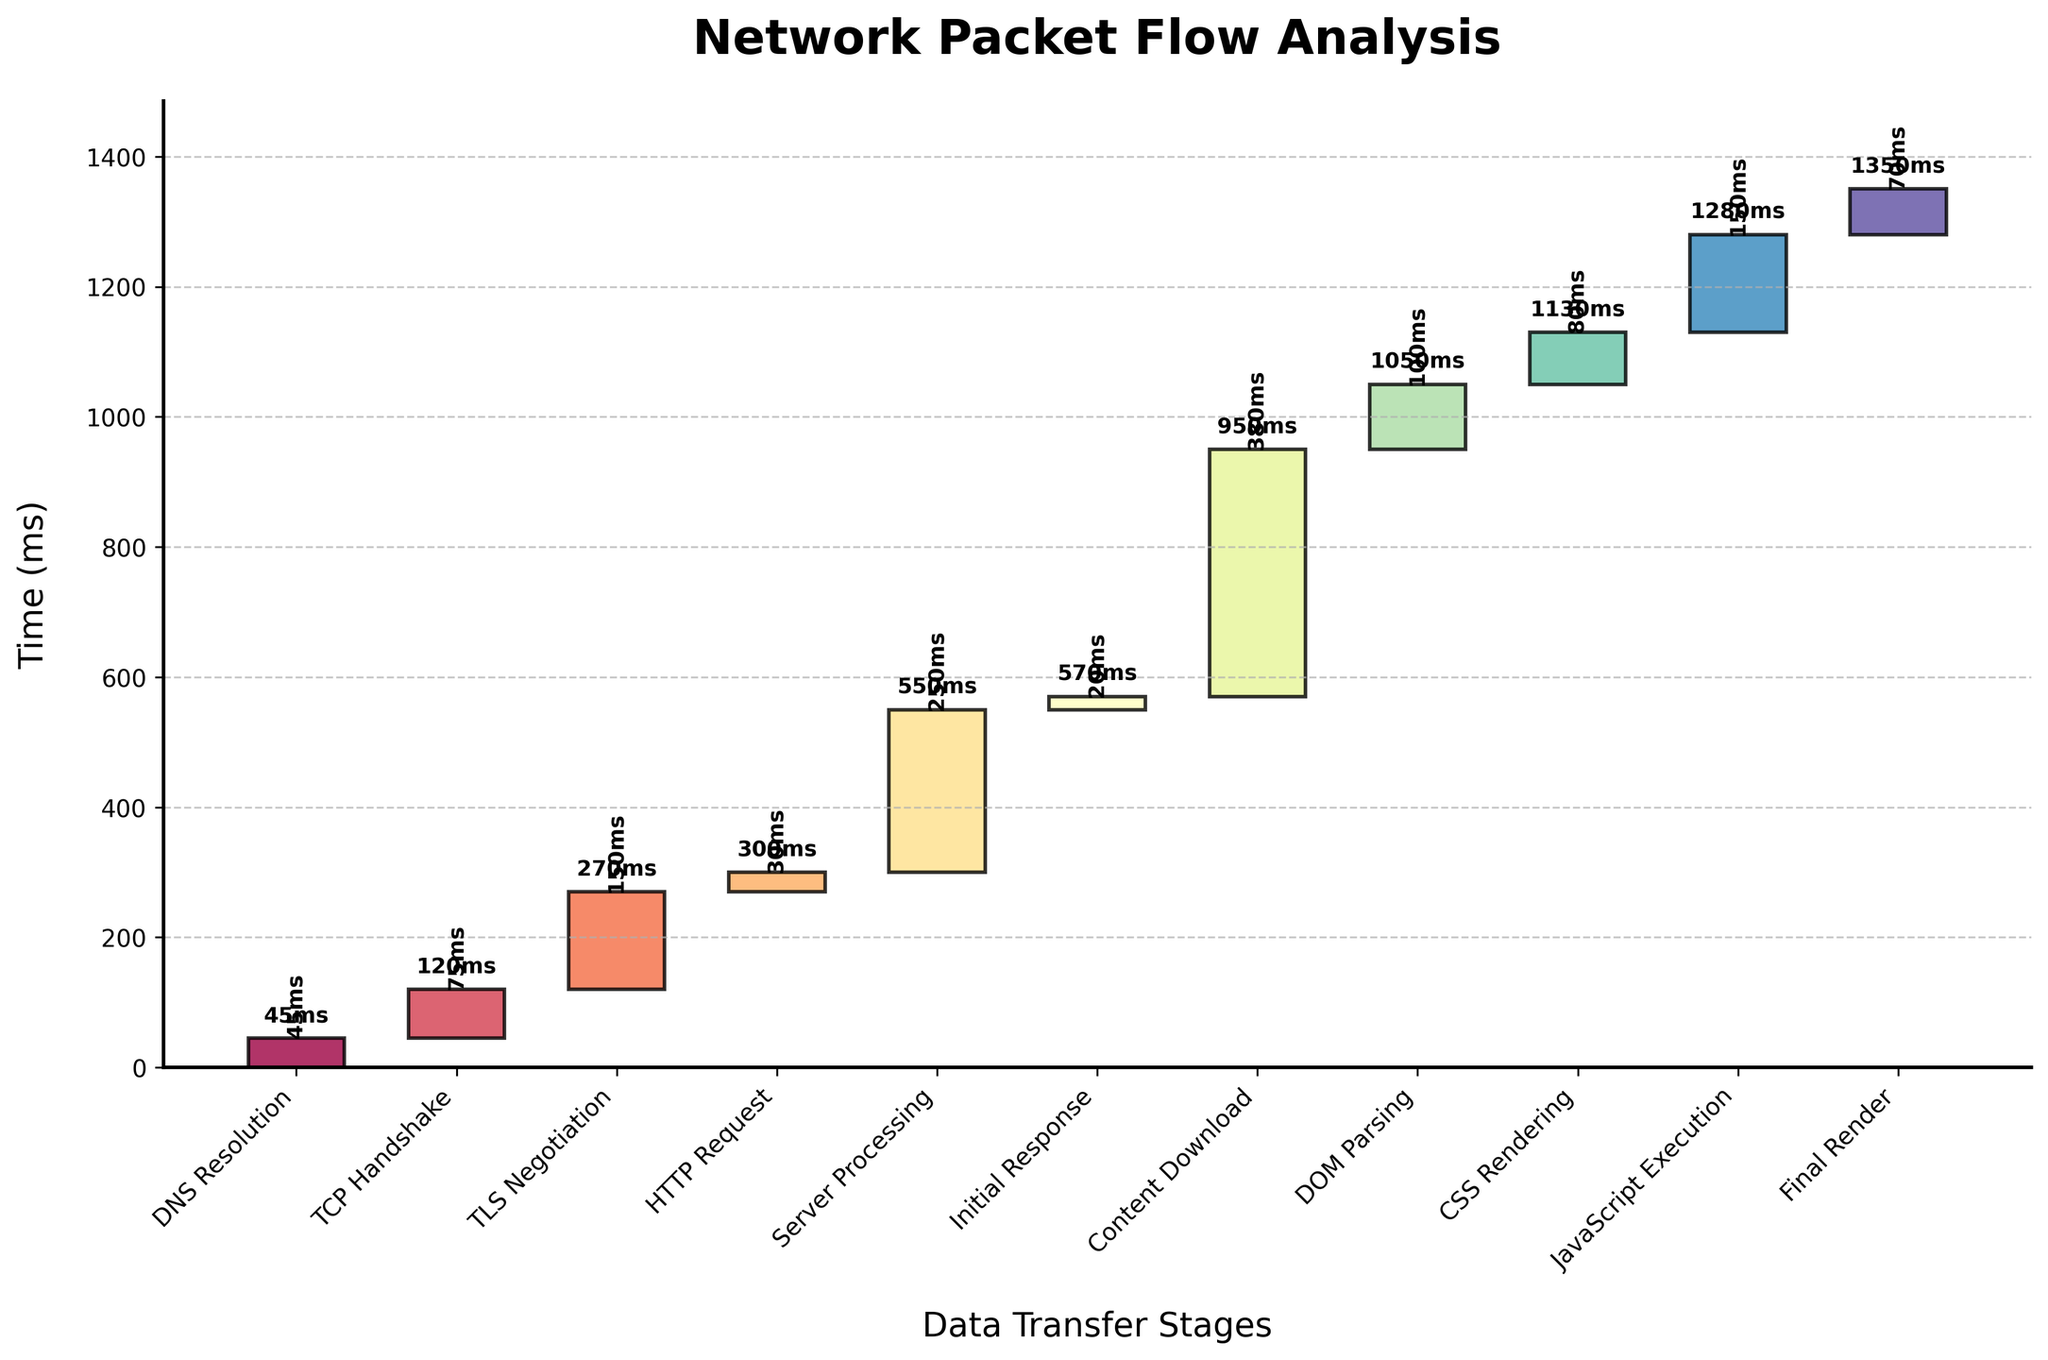Which step took the longest time? The step with the longest bar in the figure represents the longest time. Checking the figure, "Content Download" has the longest bar.
Answer: Content Download What is the cumulative time after "Server Processing"? The cumulative time is indicated at the top of the bar for "Server Processing". In the figure, it shows 550ms.
Answer: 550ms How much time did "DNS Resolution" and "TCP Handshake" take together? Sum the individual times for these steps, which are 45ms and 75ms respectively. 45ms + 75ms = 120ms
Answer: 120ms Which steps have a cumulative time of over 1000ms? By looking at the cumulative times at the top of the bars, the steps that exceed 1000ms are "DOM Parsing", "CSS Rendering", "JavaScript Execution", and "Final Render".
Answer: DOM Parsing, CSS Rendering, JavaScript Execution, Final Render How much more time does "TLS Negotiation" take compared to "DNS Resolution"? "TLS Negotiation" takes 150ms and "DNS Resolution" takes 45ms. Subtract 45ms from 150ms. 150ms - 45ms = 105ms
Answer: 105ms Which step immediately follows "TLS Negotiation"? By inspecting the order of steps from the chart, "HTTP Request" follows "TLS Negotiation".
Answer: HTTP Request How much cumulative time does it take to reach "Content Download"? The cumulative time for "Content Download" is indicated at the top of its bar, which is 950ms.
Answer: 950ms Which step has the shortest time duration? The step with the smallest bar represents the shortest time. "Initial Response" is the shortest with 20ms.
Answer: Initial Response What is the average time taken by "DOM Parsing", "CSS Rendering", and "JavaScript Execution"? First, add the times: 100ms (DOM Parsing) + 80ms (CSS Rendering) + 150ms (JavaScript Execution) = 330ms. There are 3 steps, so divide by 3. 330ms / 3 = 110ms
Answer: 110ms 